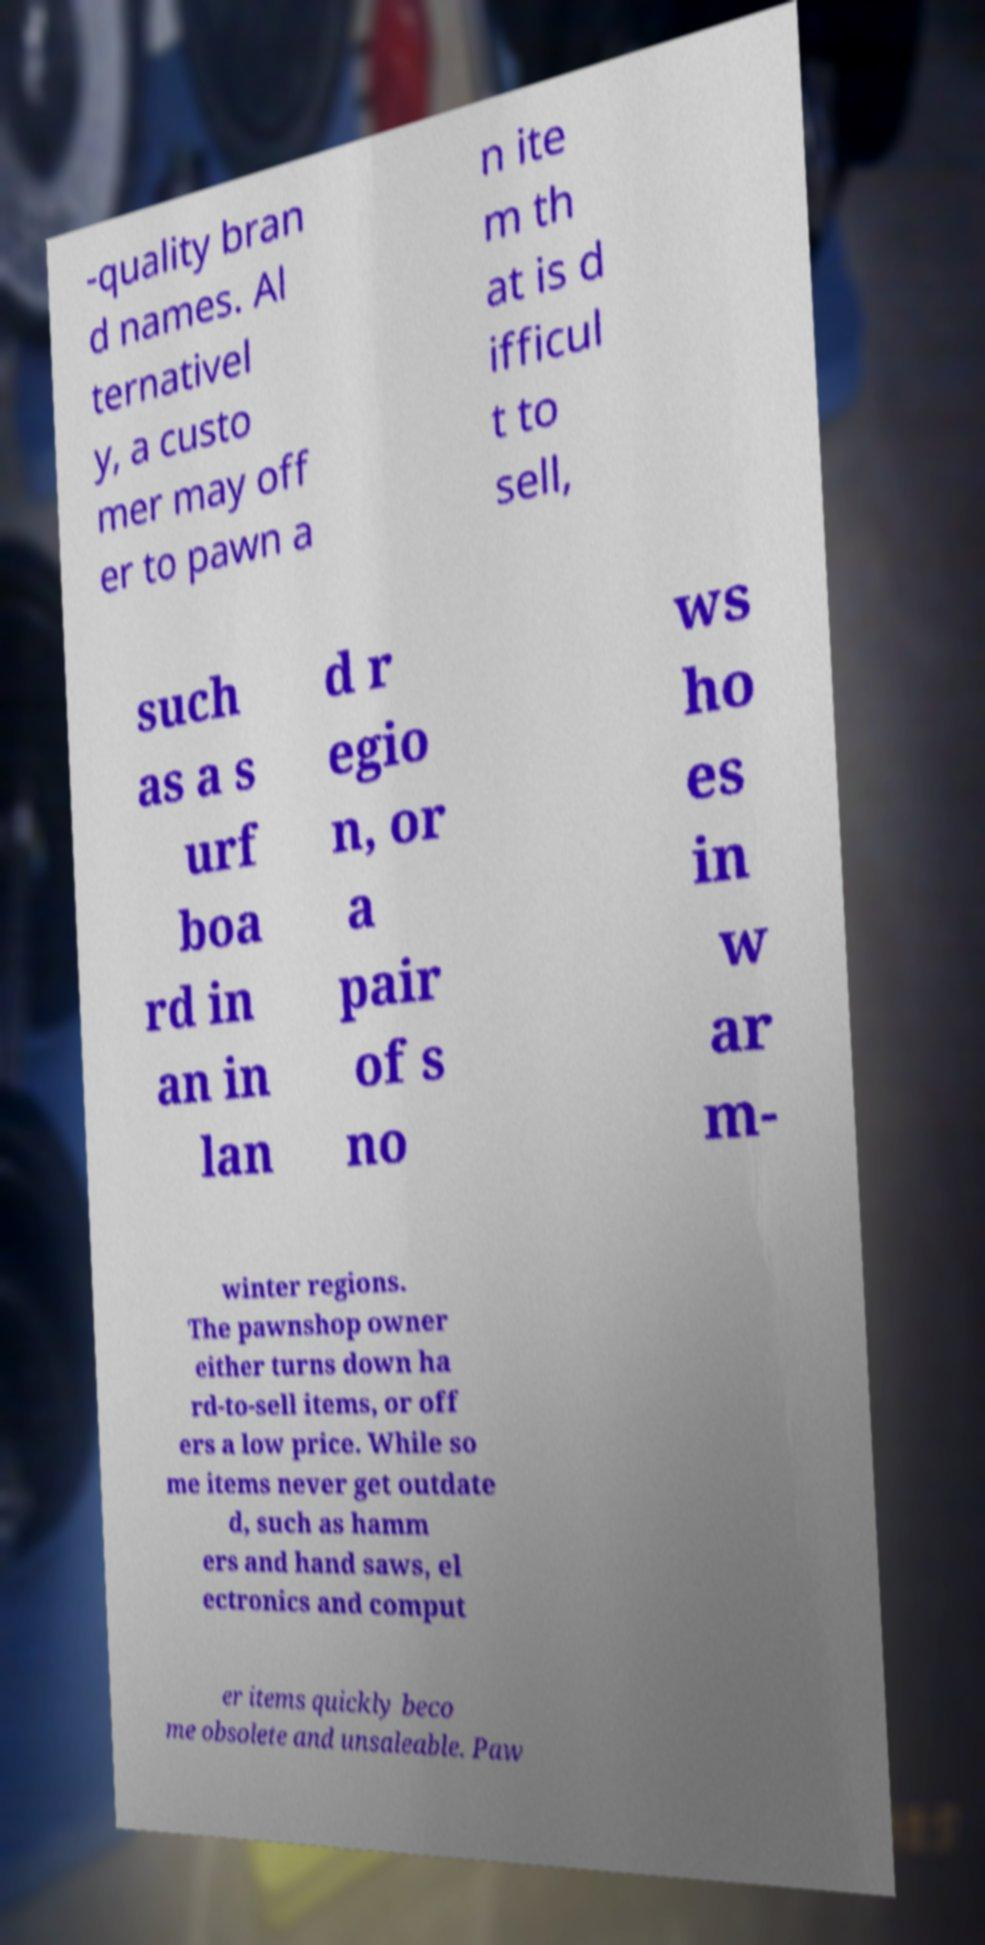For documentation purposes, I need the text within this image transcribed. Could you provide that? -quality bran d names. Al ternativel y, a custo mer may off er to pawn a n ite m th at is d ifficul t to sell, such as a s urf boa rd in an in lan d r egio n, or a pair of s no ws ho es in w ar m- winter regions. The pawnshop owner either turns down ha rd-to-sell items, or off ers a low price. While so me items never get outdate d, such as hamm ers and hand saws, el ectronics and comput er items quickly beco me obsolete and unsaleable. Paw 